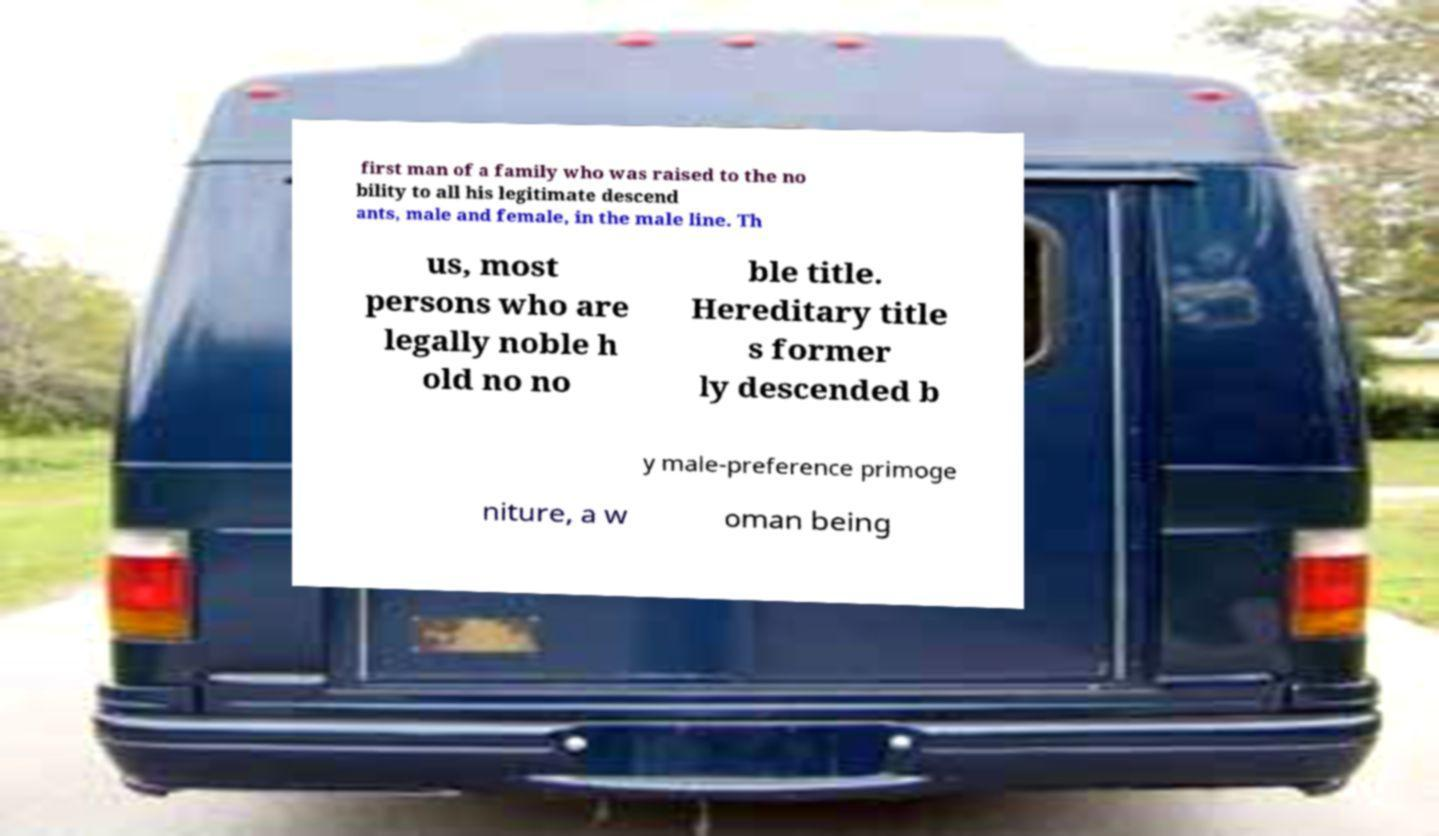For documentation purposes, I need the text within this image transcribed. Could you provide that? first man of a family who was raised to the no bility to all his legitimate descend ants, male and female, in the male line. Th us, most persons who are legally noble h old no no ble title. Hereditary title s former ly descended b y male-preference primoge niture, a w oman being 